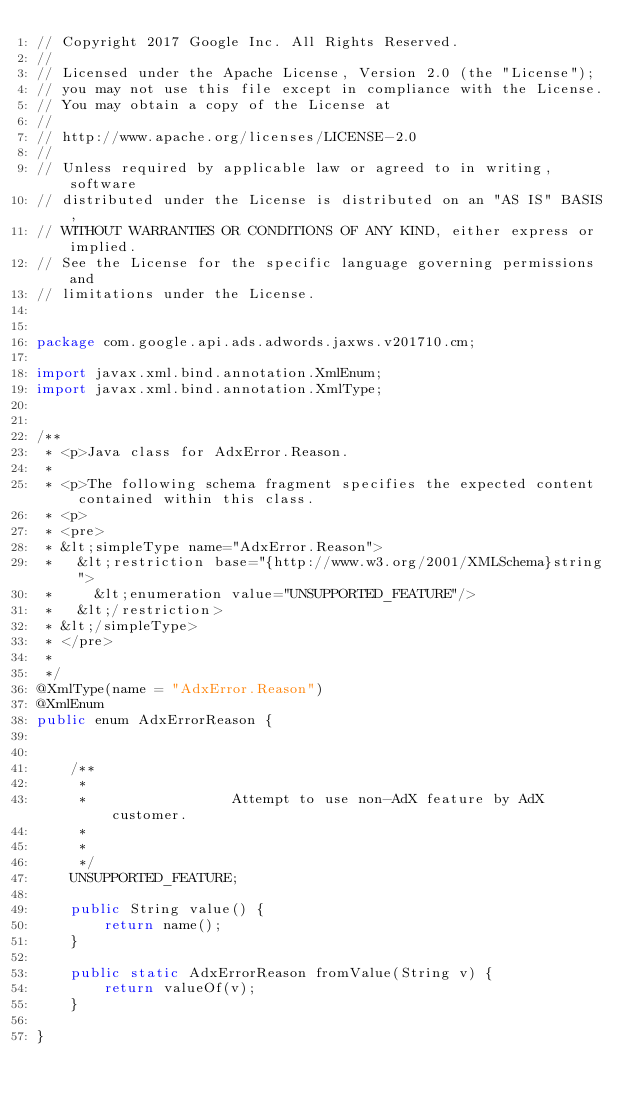Convert code to text. <code><loc_0><loc_0><loc_500><loc_500><_Java_>// Copyright 2017 Google Inc. All Rights Reserved.
//
// Licensed under the Apache License, Version 2.0 (the "License");
// you may not use this file except in compliance with the License.
// You may obtain a copy of the License at
//
// http://www.apache.org/licenses/LICENSE-2.0
//
// Unless required by applicable law or agreed to in writing, software
// distributed under the License is distributed on an "AS IS" BASIS,
// WITHOUT WARRANTIES OR CONDITIONS OF ANY KIND, either express or implied.
// See the License for the specific language governing permissions and
// limitations under the License.


package com.google.api.ads.adwords.jaxws.v201710.cm;

import javax.xml.bind.annotation.XmlEnum;
import javax.xml.bind.annotation.XmlType;


/**
 * <p>Java class for AdxError.Reason.
 * 
 * <p>The following schema fragment specifies the expected content contained within this class.
 * <p>
 * <pre>
 * &lt;simpleType name="AdxError.Reason">
 *   &lt;restriction base="{http://www.w3.org/2001/XMLSchema}string">
 *     &lt;enumeration value="UNSUPPORTED_FEATURE"/>
 *   &lt;/restriction>
 * &lt;/simpleType>
 * </pre>
 * 
 */
@XmlType(name = "AdxError.Reason")
@XmlEnum
public enum AdxErrorReason {


    /**
     * 
     *                 Attempt to use non-AdX feature by AdX customer.
     *               
     * 
     */
    UNSUPPORTED_FEATURE;

    public String value() {
        return name();
    }

    public static AdxErrorReason fromValue(String v) {
        return valueOf(v);
    }

}
</code> 